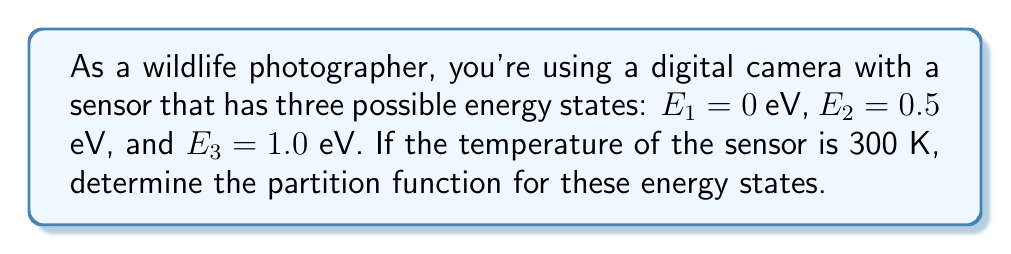Could you help me with this problem? To solve this problem, we'll follow these steps:

1) The partition function Z is defined as the sum of Boltzmann factors for all possible energy states:

   $$Z = \sum_i e^{-\beta E_i}$$

   where $\beta = \frac{1}{k_B T}$, $k_B$ is Boltzmann's constant, and T is temperature.

2) First, let's calculate $\beta$:
   $k_B = 8.617 \times 10^{-5}$ eV/K
   $T = 300$ K
   $$\beta = \frac{1}{(8.617 \times 10^{-5} \text{ eV/K})(300 \text{ K})} = 38.68 \text{ eV}^{-1}$$

3) Now, let's calculate the Boltzmann factor for each energy state:

   For $E_1 = 0$ eV: $e^{-\beta E_1} = e^{-38.68 \times 0} = 1$
   
   For $E_2 = 0.5$ eV: $e^{-\beta E_2} = e^{-38.68 \times 0.5} = e^{-19.34} = 3.98 \times 10^{-9}$
   
   For $E_3 = 1.0$ eV: $e^{-\beta E_3} = e^{-38.68 \times 1.0} = e^{-38.68} = 1.58 \times 10^{-17}$

4) The partition function is the sum of these Boltzmann factors:

   $$Z = 1 + 3.98 \times 10^{-9} + 1.58 \times 10^{-17}$$

5) Simplifying:

   $$Z \approx 1.00000000398$$
Answer: $Z \approx 1.00000000398$ 